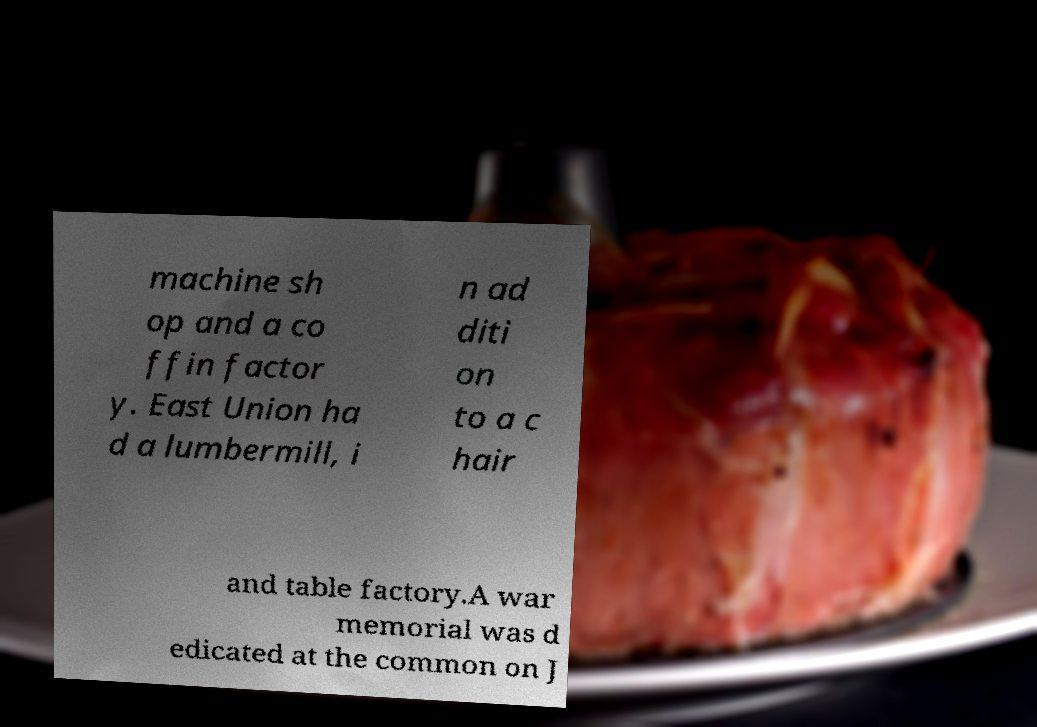I need the written content from this picture converted into text. Can you do that? machine sh op and a co ffin factor y. East Union ha d a lumbermill, i n ad diti on to a c hair and table factory.A war memorial was d edicated at the common on J 